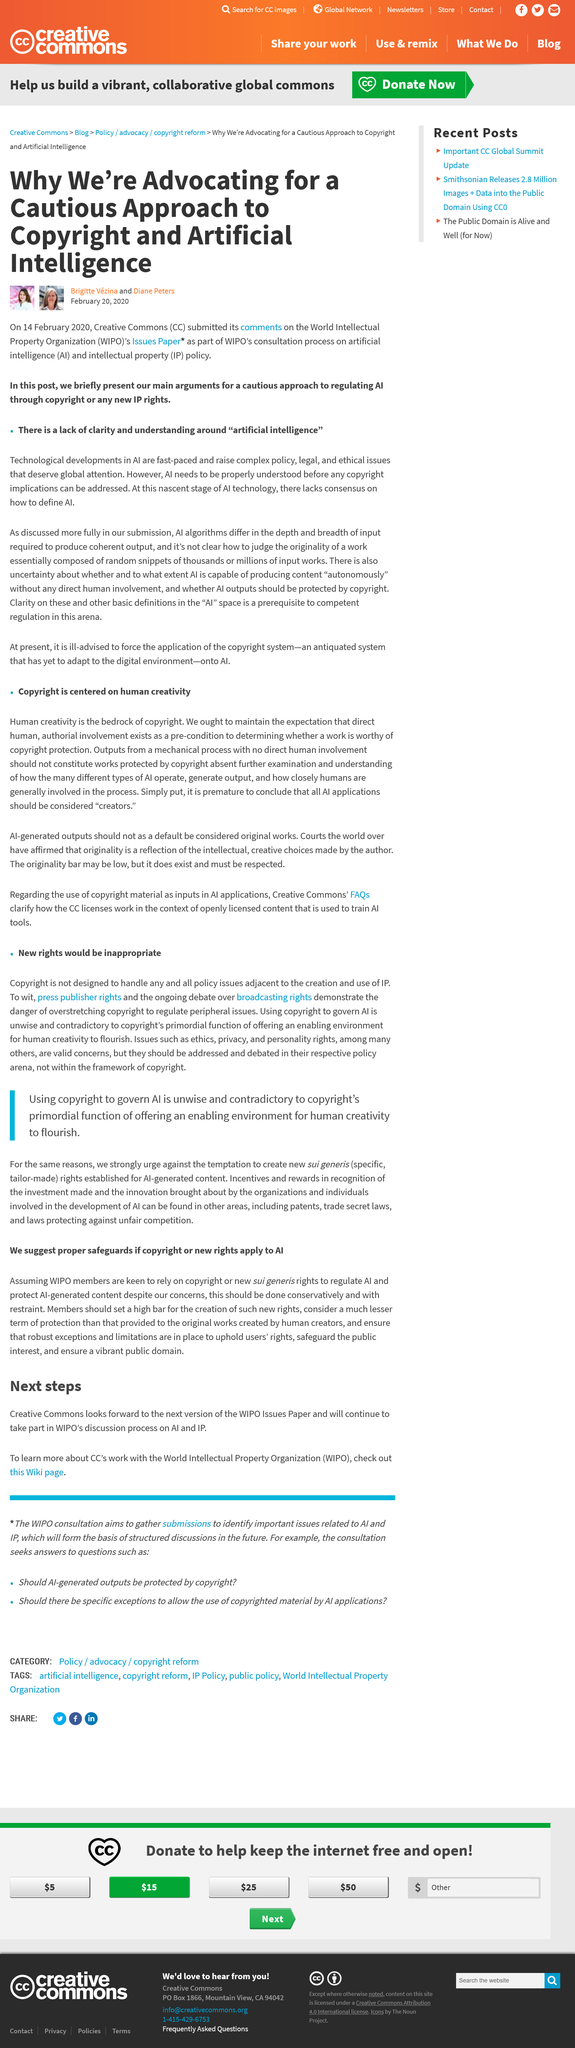List a handful of essential elements in this visual. On February 14, 2020, CC submitted papers to WIPO. The Creative Commons is anticipating the release of the next version of the WIPO Issues Paper, which will cover important topics related to intellectual property. The World Intellectual Property Organization (WIPO) is seeking input from the public to identify important issues related to artificial intelligence (AI) and intellectual property (IP). This article was written by two individuals. Structured discussions in the future will be based on important issues related to AI and IP. 